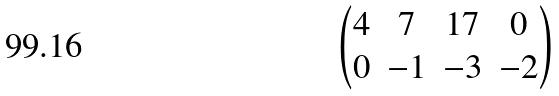<formula> <loc_0><loc_0><loc_500><loc_500>\begin{pmatrix} 4 & 7 & 1 7 & 0 \\ 0 & - 1 & - 3 & - 2 \end{pmatrix}</formula> 